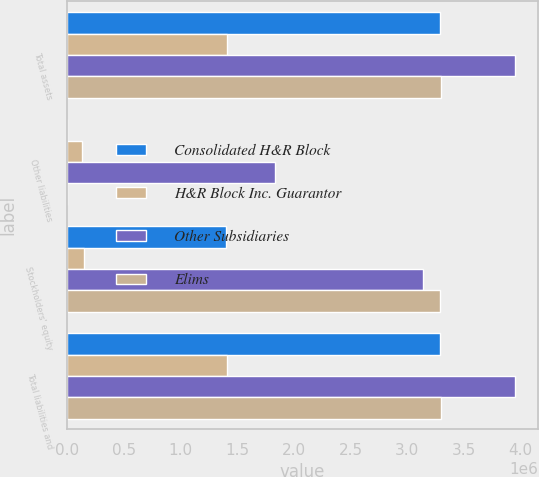<chart> <loc_0><loc_0><loc_500><loc_500><stacked_bar_chart><ecel><fcel>Total assets<fcel>Other liabilities<fcel>Stockholders' equity<fcel>Total liabilities and<nl><fcel>Consolidated H&R Block<fcel>3.28947e+06<fcel>2<fcel>1.40586e+06<fcel>3.28947e+06<nl><fcel>H&R Block Inc. Guarantor<fcel>1.41348e+06<fcel>130362<fcel>151211<fcel>1.41348e+06<nl><fcel>Other Subsidiaries<fcel>3.95243e+06<fcel>1.83648e+06<fcel>3.13822e+06<fcel>3.95243e+06<nl><fcel>Elims<fcel>3.29566e+06<fcel>12<fcel>3.28944e+06<fcel>3.29566e+06<nl></chart> 